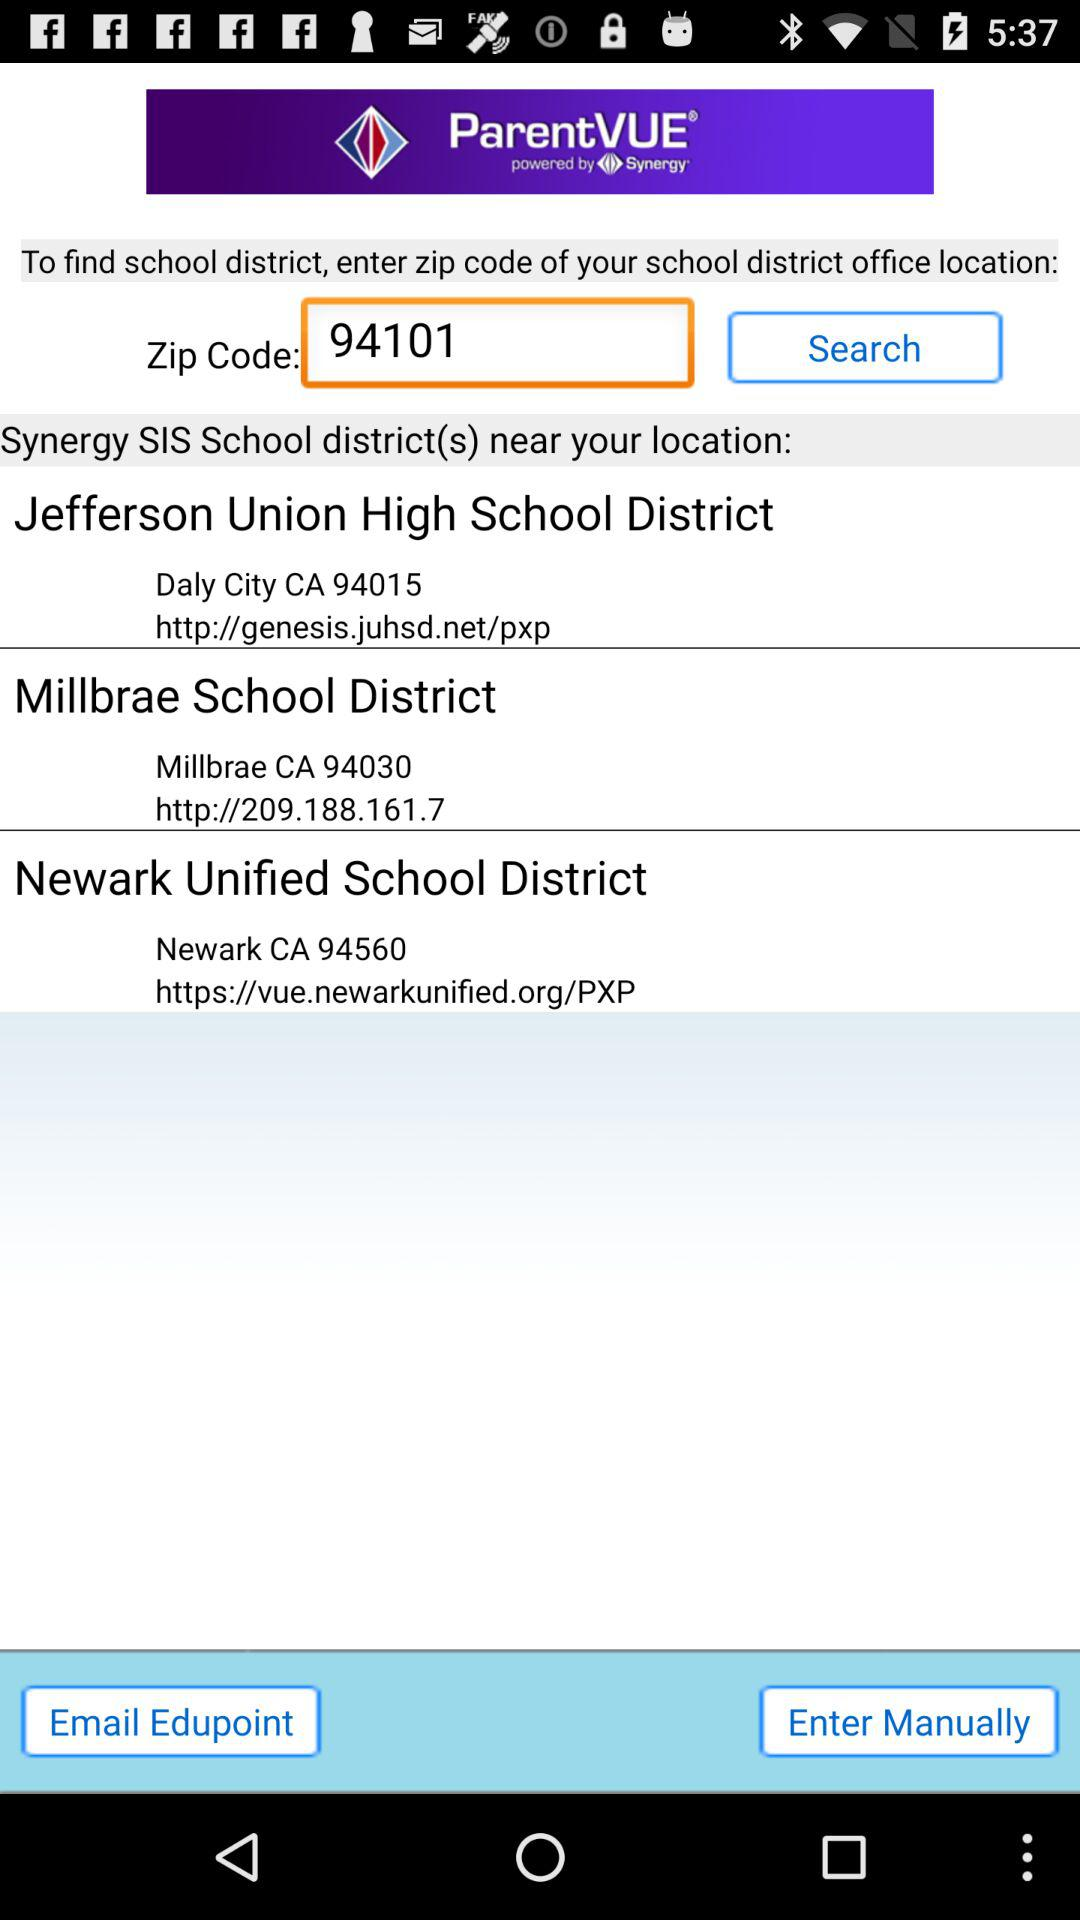What is the zip code of "Newark Unified School District"? The zip code is 94560. 